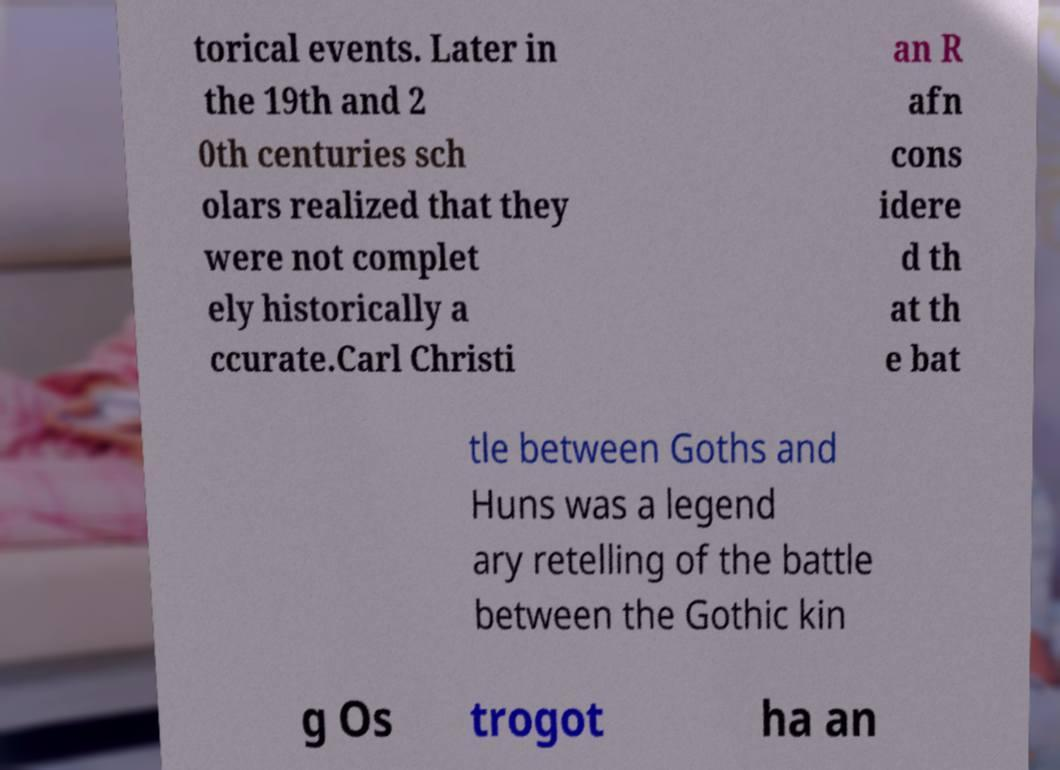There's text embedded in this image that I need extracted. Can you transcribe it verbatim? torical events. Later in the 19th and 2 0th centuries sch olars realized that they were not complet ely historically a ccurate.Carl Christi an R afn cons idere d th at th e bat tle between Goths and Huns was a legend ary retelling of the battle between the Gothic kin g Os trogot ha an 